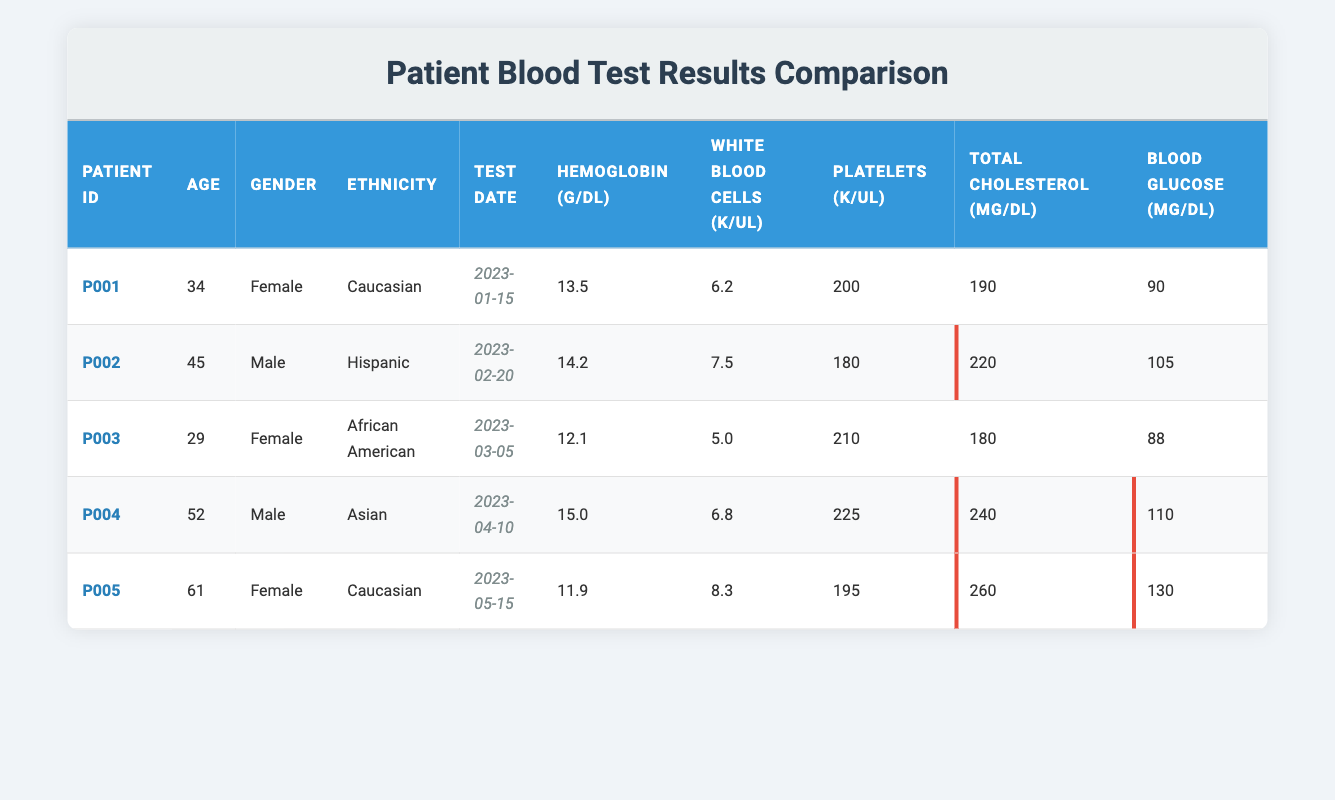What is the hemoglobin level of Patient P003? The hemoglobin level for Patient P003 can be found directly in the table under the column for Hemoglobin. For Patient P003, the table shows that the hemoglobin level is 12.1 g/dL.
Answer: 12.1 g/dL How many platelets does Patient P005 have? To find the platelet count for Patient P005, refer to the "Platelets (K/uL)" column in the table. The table indicates that Patient P005 has 195 K/uL platelets.
Answer: 195 K/uL What is the average cholesterol level among all patients? To calculate the average cholesterol level, sum the cholesterol values from all patients: (190 + 220 + 180 + 240 + 260) = 1090. Then divide by the number of patients (5), which results in 1090/5 = 218.
Answer: 218 mg/dL Is the average blood glucose level for male patients higher than for female patients? First, find the blood glucose levels for male patients: P002 (105), P004 (110). The average for males is (105 + 110) / 2 = 107.5. For females: P001 (90), P003 (88), P005 (130), the average is (90 + 88 + 130) / 3 = 102.67. Since 107.5 > 102.67, the average for males is higher.
Answer: Yes Which patient has the highest platelet count and what is that count? Examine the "Platelets (K/uL)" values for each patient: P001 (200), P002 (180), P003 (210), P004 (225), P005 (195). The highest value is 225 from Patient P004.
Answer: Patient P004 has 225 K/uL platelets 